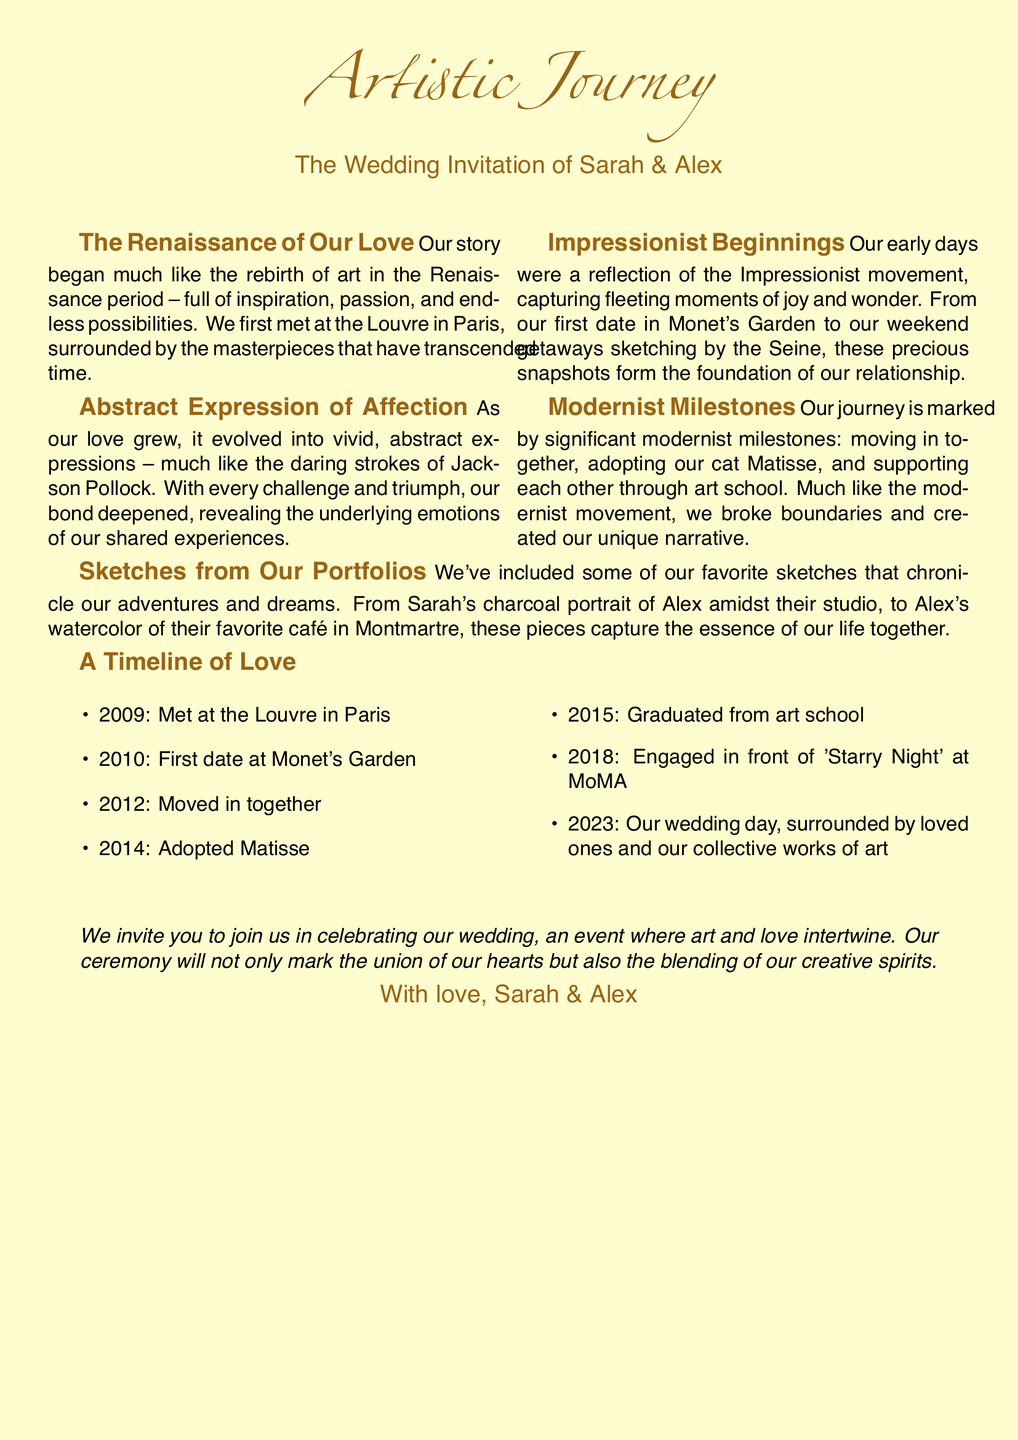What is the title of the document? The title of the document is prominently displayed at the top, labeled as "Artistic Journey."
Answer: Artistic Journey Who are the couple getting married? The names of the couple can be found in the main heading of the invitation.
Answer: Sarah & Alex What year did Sarah and Alex meet? The year they met is listed under the timeline of love section.
Answer: 2009 In which location did they first meet? The location of their first meeting is mentioned in the narrative section.
Answer: Louvre What art movement is associated with their early relationship? The text describes their early relationship using a specific art movement as a metaphor.
Answer: Impressionism What significant event happened in 2018? The timeline includes key events; the one for this year is specified as an engagement.
Answer: Engaged Which pet did they adopt? The timeline mentions this milestone along with the year they adopted it.
Answer: Matisse What type of artwork is featured in the sketches? The document describes the nature of the sketches included in the invitation.
Answer: Charcoal portrait and watercolor What is the main theme of their wedding invitation? The invitation narratively ties together art and personal storytelling, which defines its theme.
Answer: Creative journey 